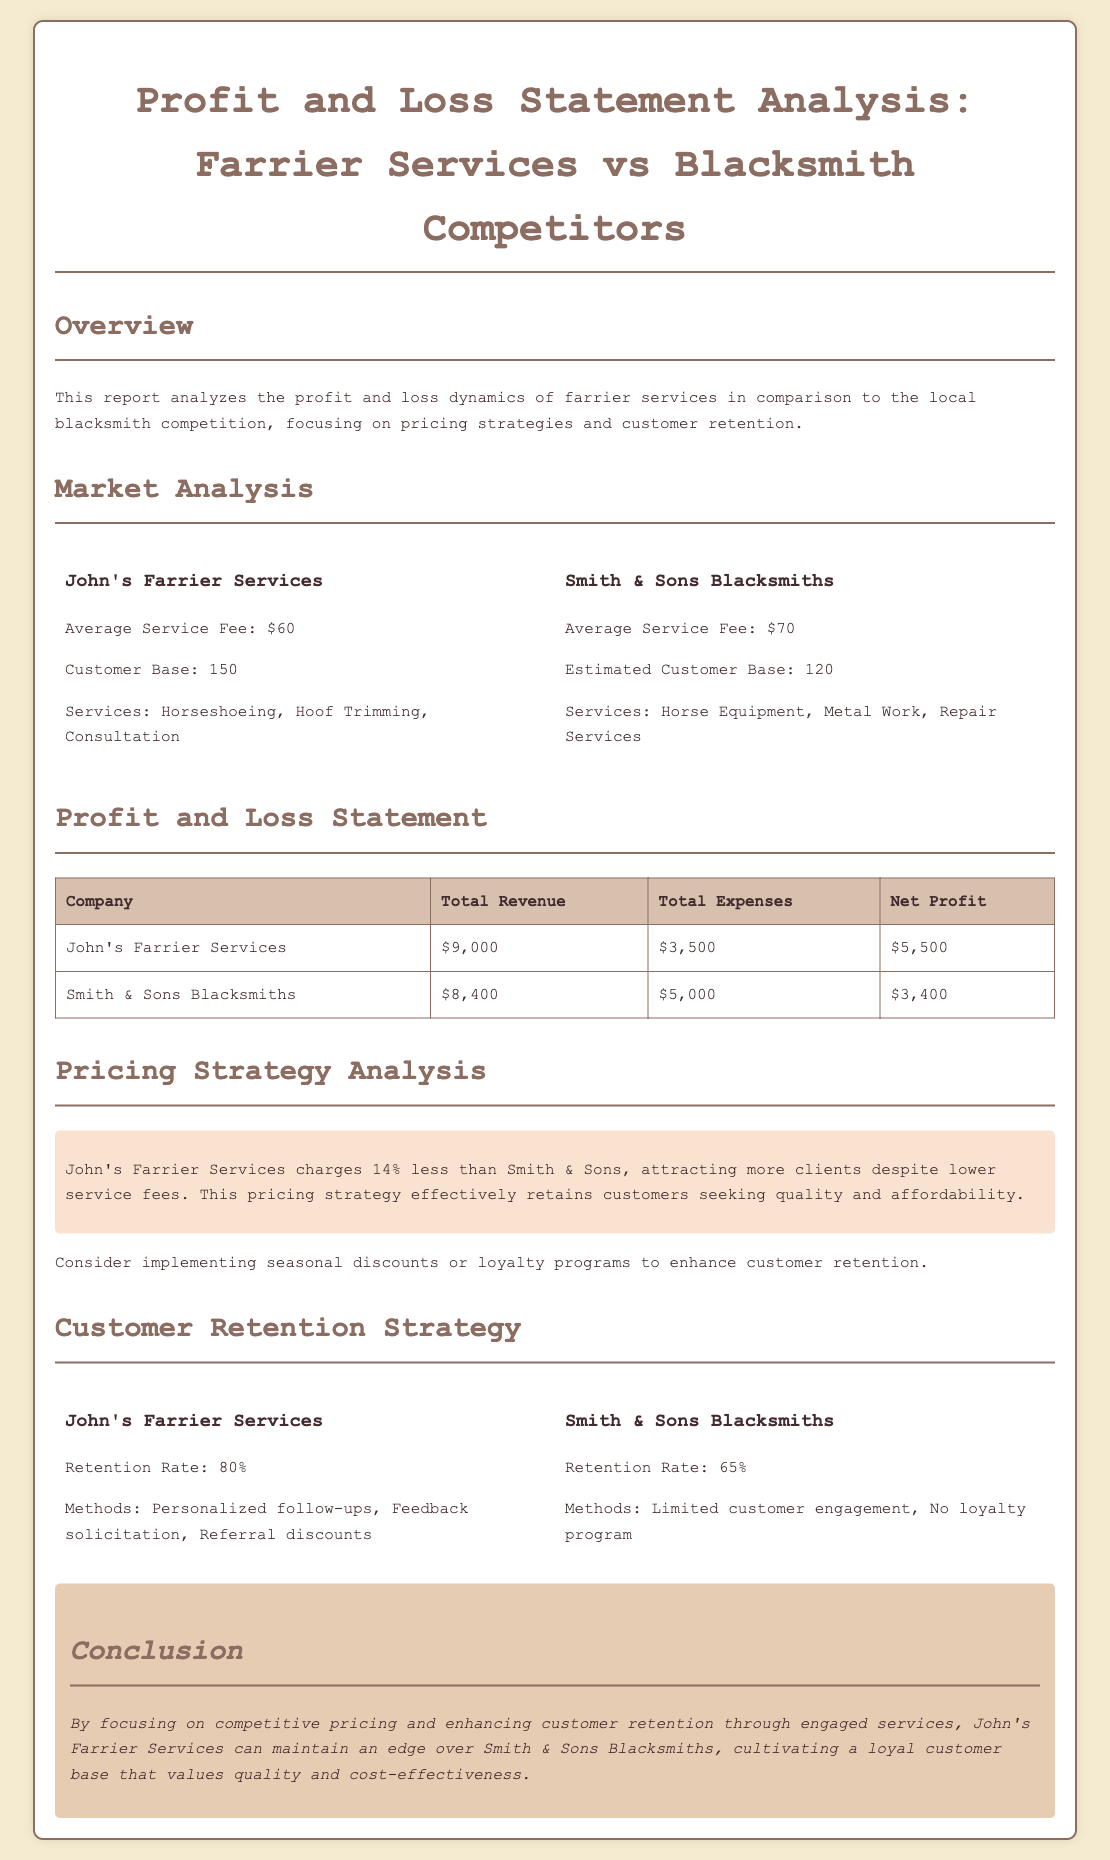What is the average service fee for John's Farrier Services? The document states that the average service fee for John's Farrier Services is $60.
Answer: $60 What is the net profit of Smith & Sons Blacksmiths? The document lists the net profit of Smith & Sons Blacksmiths as $3,400.
Answer: $3,400 What is the total revenue for John's Farrier Services? According to the document, the total revenue for John's Farrier Services is $9,000.
Answer: $9,000 What is the customer retention rate for John's Farrier Services? The retention rate for John's Farrier Services is mentioned in the document as 80%.
Answer: 80% Which company has a higher average service fee? The document indicates that Smith & Sons Blacksmiths has an average service fee of $70, which is higher than John's.
Answer: Smith & Sons Blacksmiths How much lower is John's average service fee compared to Smith & Sons? The document states that John's average service fee is 14% less than Smith & Sons' fee of $70.
Answer: 14% What customer engagement methods does Smith & Sons use? The document notes that Smith & Sons Blacksmiths has limited customer engagement and no loyalty program.
Answer: Limited customer engagement What type of pricing strategy does John's Farrier Services use? The document describes John's pricing strategy as competitive and focused on affordability, reflecting a lower fee compared to competitors.
Answer: Competitive pricing What recommendations are made for improving customer retention? The document suggests implementing seasonal discounts or loyalty programs to enhance customer retention.
Answer: Seasonal discounts or loyalty programs 